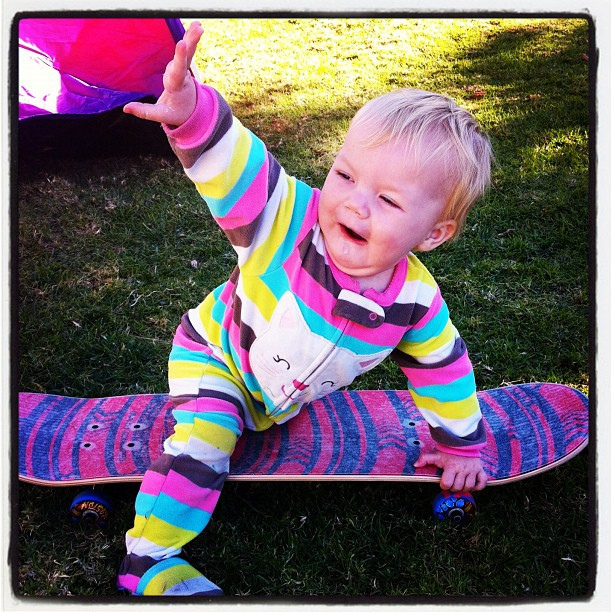<image>What animal can been seen in this picture? It is unclear if there is an animal in the picture. It could possibly be a cat. What animal can been seen in this picture? I am not sure what animal can be seen in the picture, but it seems to be a cat. 